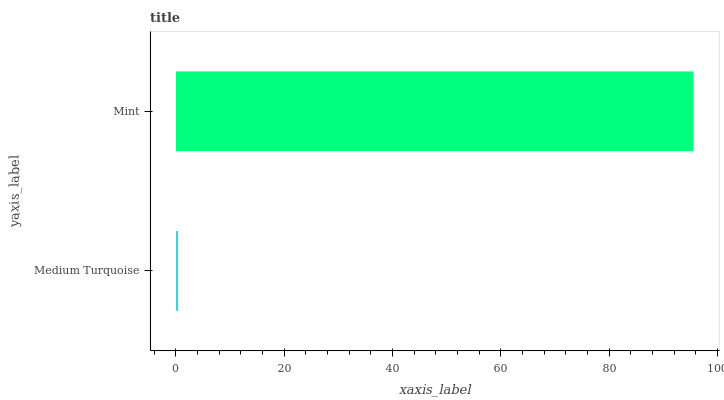Is Medium Turquoise the minimum?
Answer yes or no. Yes. Is Mint the maximum?
Answer yes or no. Yes. Is Mint the minimum?
Answer yes or no. No. Is Mint greater than Medium Turquoise?
Answer yes or no. Yes. Is Medium Turquoise less than Mint?
Answer yes or no. Yes. Is Medium Turquoise greater than Mint?
Answer yes or no. No. Is Mint less than Medium Turquoise?
Answer yes or no. No. Is Mint the high median?
Answer yes or no. Yes. Is Medium Turquoise the low median?
Answer yes or no. Yes. Is Medium Turquoise the high median?
Answer yes or no. No. Is Mint the low median?
Answer yes or no. No. 